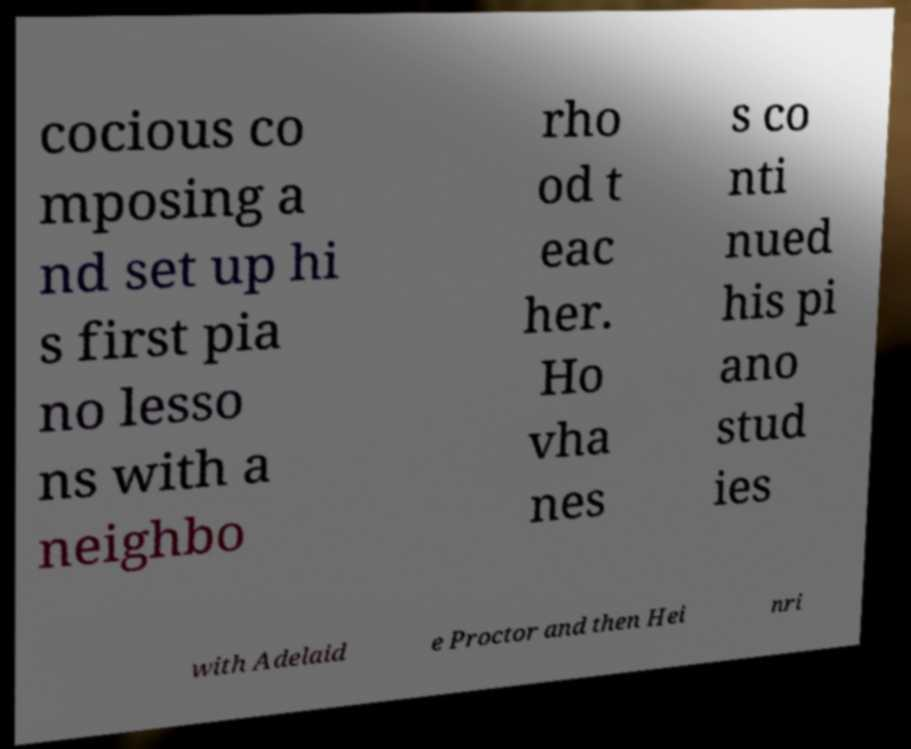What messages or text are displayed in this image? I need them in a readable, typed format. cocious co mposing a nd set up hi s first pia no lesso ns with a neighbo rho od t eac her. Ho vha nes s co nti nued his pi ano stud ies with Adelaid e Proctor and then Hei nri 